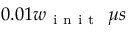Convert formula to latex. <formula><loc_0><loc_0><loc_500><loc_500>0 . 0 1 w _ { i n i t } \ \mu s</formula> 